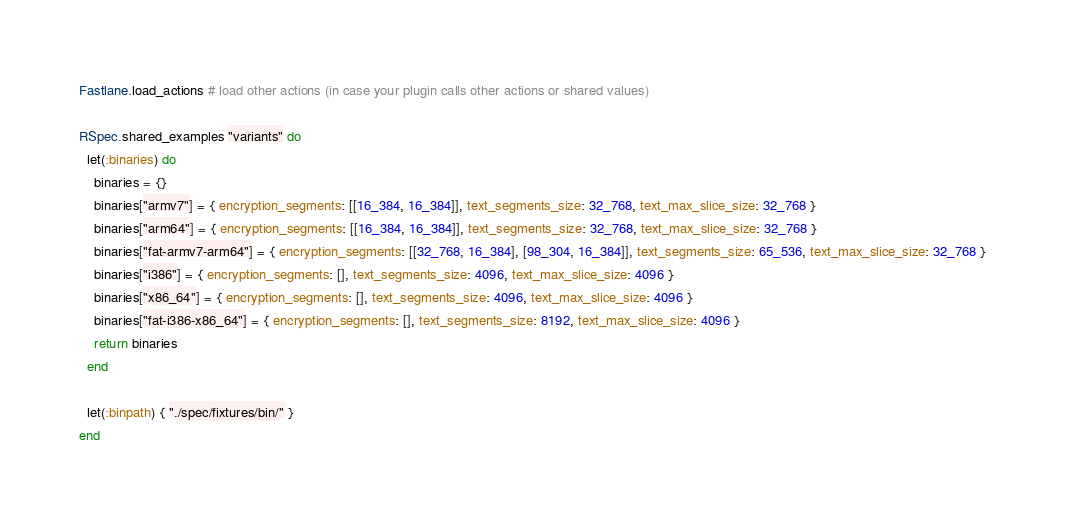<code> <loc_0><loc_0><loc_500><loc_500><_Ruby_>
Fastlane.load_actions # load other actions (in case your plugin calls other actions or shared values)

RSpec.shared_examples "variants" do
  let(:binaries) do
    binaries = {}
    binaries["armv7"] = { encryption_segments: [[16_384, 16_384]], text_segments_size: 32_768, text_max_slice_size: 32_768 }
    binaries["arm64"] = { encryption_segments: [[16_384, 16_384]], text_segments_size: 32_768, text_max_slice_size: 32_768 }
    binaries["fat-armv7-arm64"] = { encryption_segments: [[32_768, 16_384], [98_304, 16_384]], text_segments_size: 65_536, text_max_slice_size: 32_768 }
    binaries["i386"] = { encryption_segments: [], text_segments_size: 4096, text_max_slice_size: 4096 }
    binaries["x86_64"] = { encryption_segments: [], text_segments_size: 4096, text_max_slice_size: 4096 }
    binaries["fat-i386-x86_64"] = { encryption_segments: [], text_segments_size: 8192, text_max_slice_size: 4096 }
    return binaries
  end

  let(:binpath) { "./spec/fixtures/bin/" }
end
</code> 